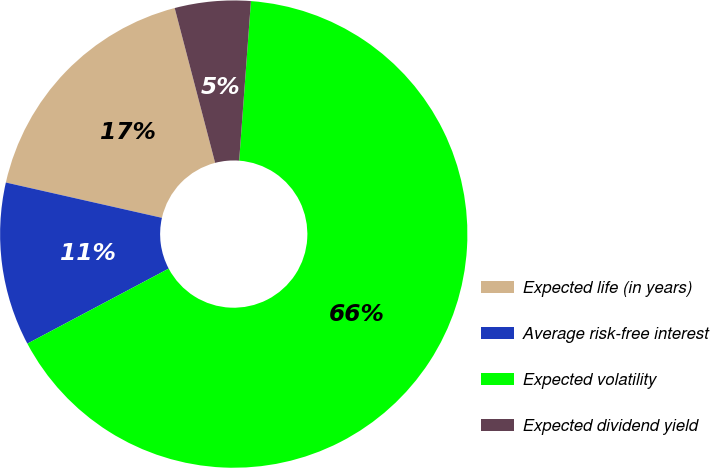Convert chart to OTSL. <chart><loc_0><loc_0><loc_500><loc_500><pie_chart><fcel>Expected life (in years)<fcel>Average risk-free interest<fcel>Expected volatility<fcel>Expected dividend yield<nl><fcel>17.39%<fcel>11.31%<fcel>66.06%<fcel>5.24%<nl></chart> 